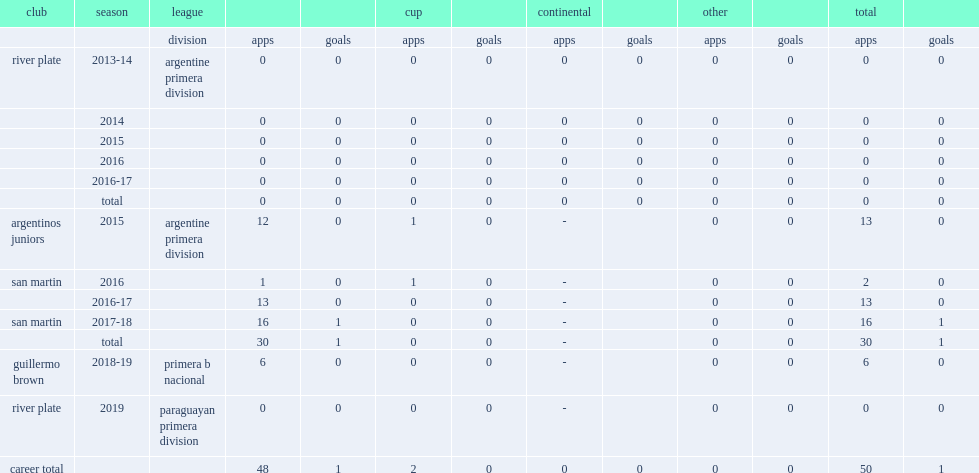Which league did emiliano aguero appear in river plate (a) in 2019? Paraguayan primera division. 